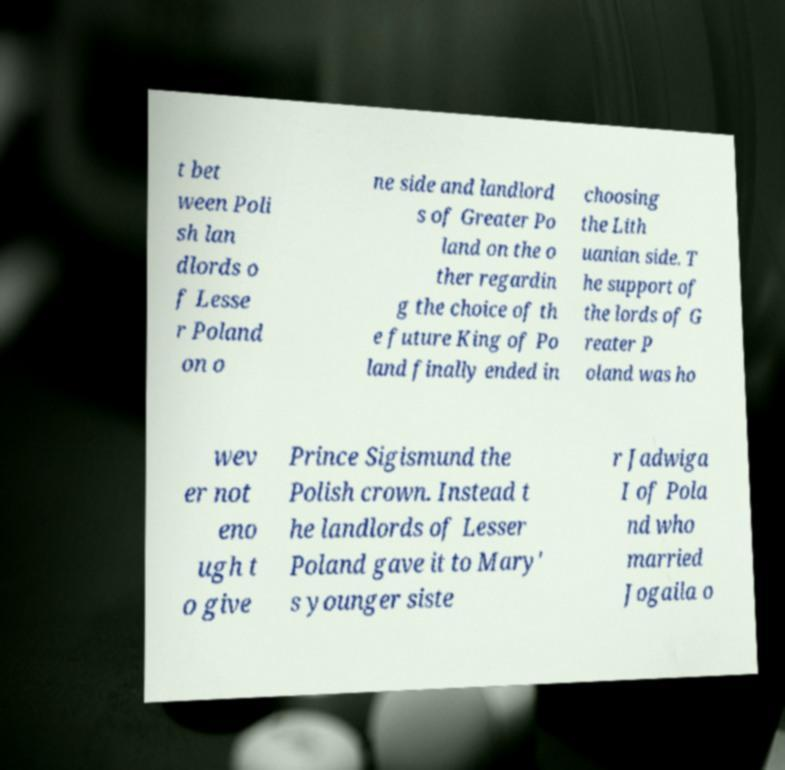Please read and relay the text visible in this image. What does it say? t bet ween Poli sh lan dlords o f Lesse r Poland on o ne side and landlord s of Greater Po land on the o ther regardin g the choice of th e future King of Po land finally ended in choosing the Lith uanian side. T he support of the lords of G reater P oland was ho wev er not eno ugh t o give Prince Sigismund the Polish crown. Instead t he landlords of Lesser Poland gave it to Mary' s younger siste r Jadwiga I of Pola nd who married Jogaila o 